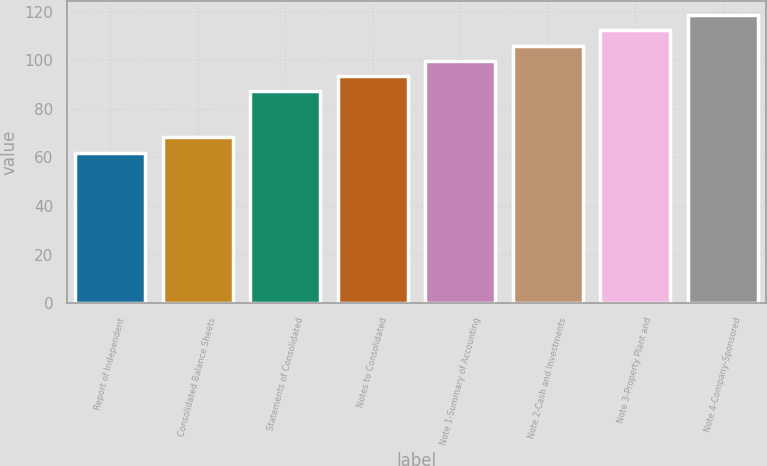<chart> <loc_0><loc_0><loc_500><loc_500><bar_chart><fcel>Report of Independent<fcel>Consolidated Balance Sheets<fcel>Statements of Consolidated<fcel>Notes to Consolidated<fcel>Note 1-Summary of Accounting<fcel>Note 2-Cash and Investments<fcel>Note 3-Property Plant and<fcel>Note 4-Company-Sponsored<nl><fcel>62<fcel>68.3<fcel>87.2<fcel>93.5<fcel>99.8<fcel>106.1<fcel>112.4<fcel>118.7<nl></chart> 